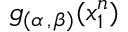Convert formula to latex. <formula><loc_0><loc_0><loc_500><loc_500>g _ { ( \alpha \, , \, \beta ) } ( x _ { 1 } ^ { n } )</formula> 